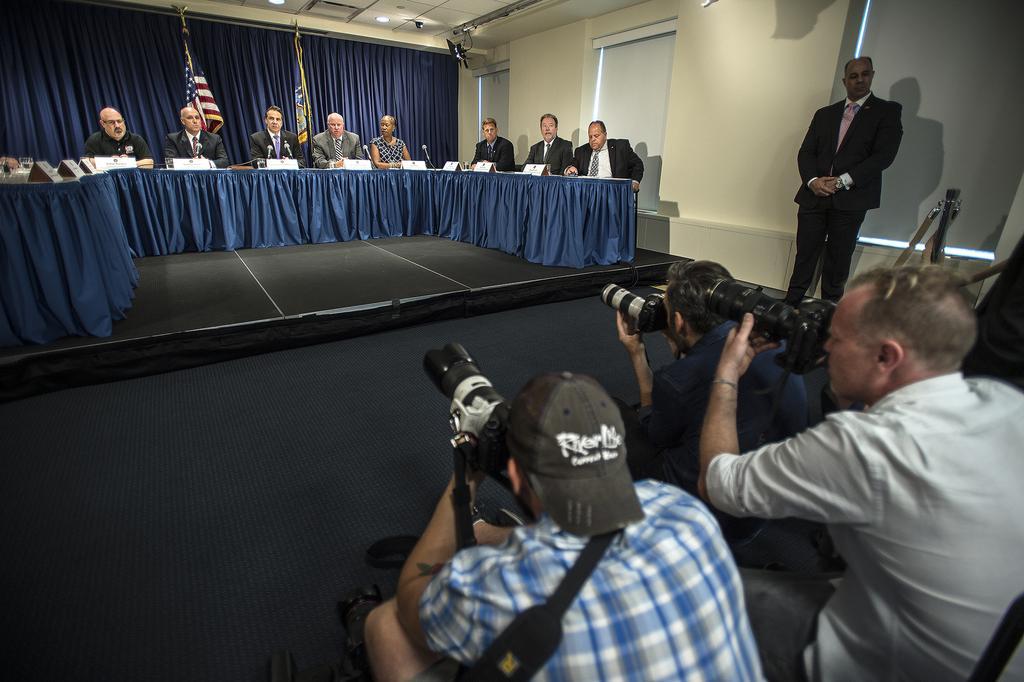Please provide a concise description of this image. In this image, we can see a few people. Among them, some people are holding cameras. We can also see the ground and a table covered with a cloth and some objects on it. We can see some curtains, flags. We can see the roof with lights. There is a wall with some windows. There is a camera stand. 